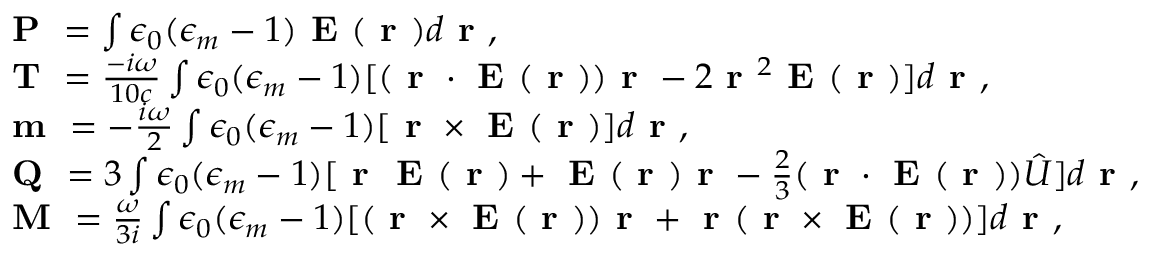<formula> <loc_0><loc_0><loc_500><loc_500>\begin{array} { r l } & { P = \int \epsilon _ { 0 } ( \epsilon _ { m } - 1 ) E ( r ) d r , } \\ & { { T = \frac { - i \omega } { 1 0 c } \int \epsilon _ { 0 } ( \epsilon _ { m } - 1 ) [ ( r \cdot E ( r ) ) r - 2 r ^ { 2 } E ( r ) ] d r } , } \\ & { m = - \frac { i \omega } { 2 } \int \epsilon _ { 0 } ( \epsilon _ { m } - 1 ) [ r \times E ( r ) ] d r , } \\ & { Q = 3 \int \epsilon _ { 0 } ( \epsilon _ { m } - 1 ) [ r E ( r ) + E ( r ) r - \frac { 2 } { 3 } ( r \cdot E ( r ) ) \hat { U } ] d r , } \\ & { M = \frac { \omega } { 3 i } \int \epsilon _ { 0 } ( \epsilon _ { m } - 1 ) [ ( r \times E ( r ) ) r + r ( r \times E ( r ) ) ] d r , } \end{array}</formula> 